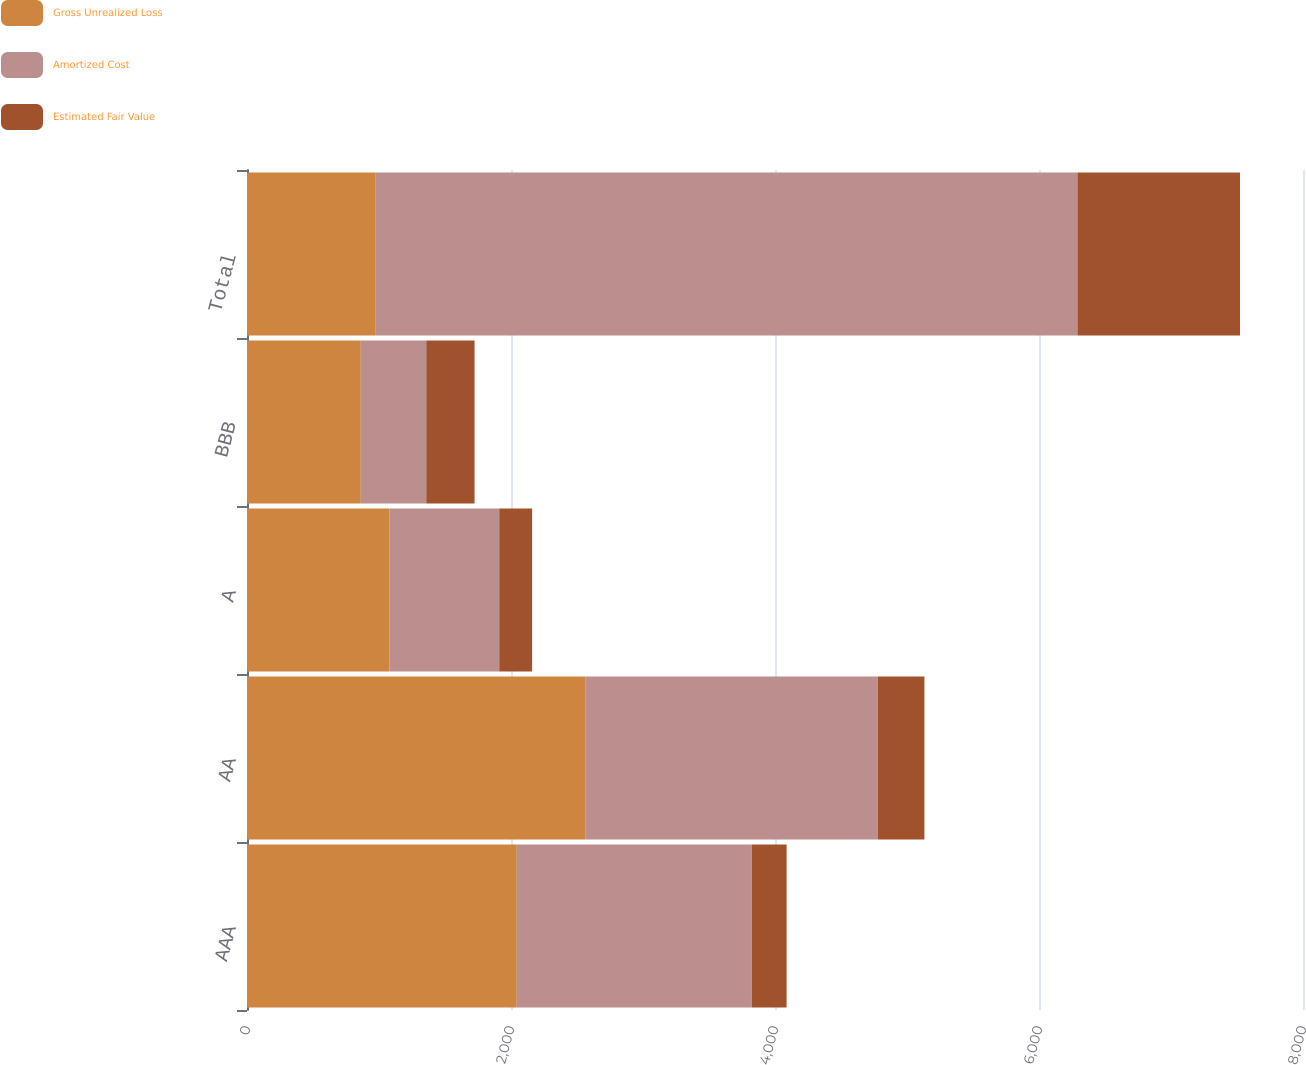Convert chart. <chart><loc_0><loc_0><loc_500><loc_500><stacked_bar_chart><ecel><fcel>AAA<fcel>AA<fcel>A<fcel>BBB<fcel>Total<nl><fcel>Gross Unrealized Loss<fcel>2044<fcel>2566<fcel>1080<fcel>862<fcel>971<nl><fcel>Amortized Cost<fcel>1780<fcel>2213<fcel>831<fcel>496<fcel>5320<nl><fcel>Estimated Fair Value<fcel>264<fcel>353<fcel>249<fcel>366<fcel>1232<nl></chart> 